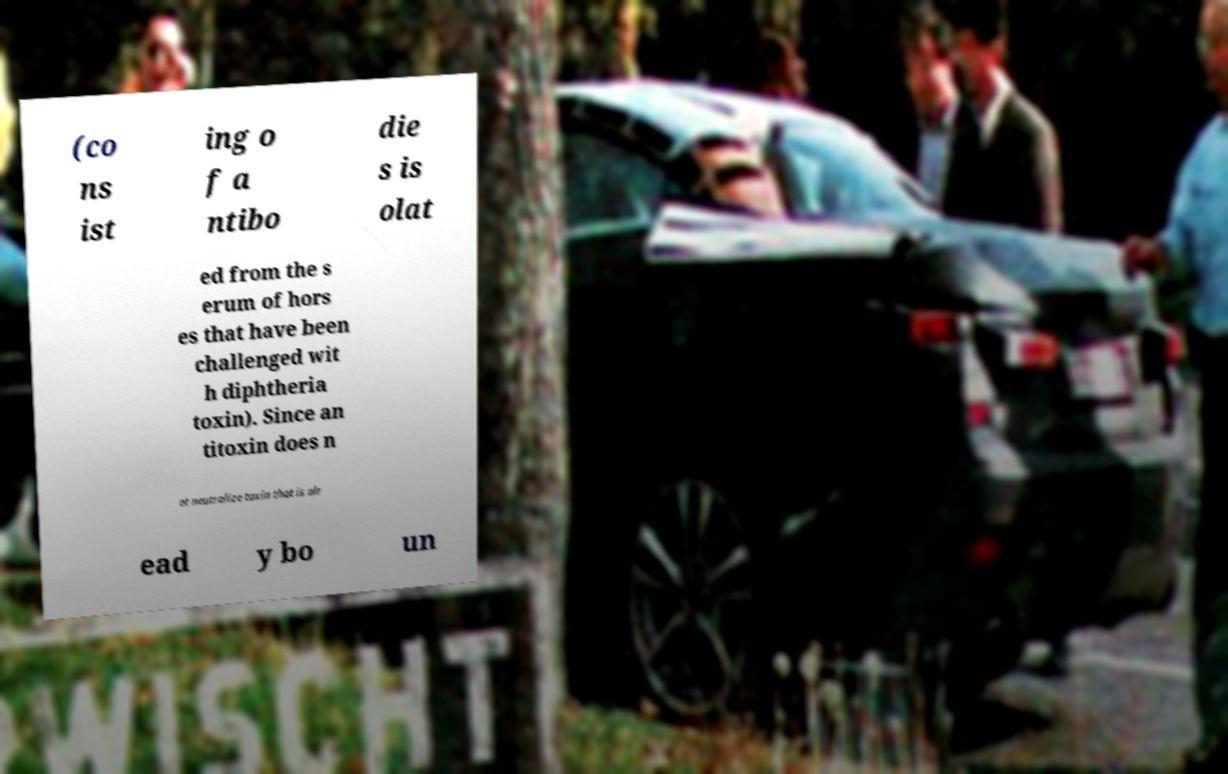For documentation purposes, I need the text within this image transcribed. Could you provide that? (co ns ist ing o f a ntibo die s is olat ed from the s erum of hors es that have been challenged wit h diphtheria toxin). Since an titoxin does n ot neutralize toxin that is alr ead y bo un 